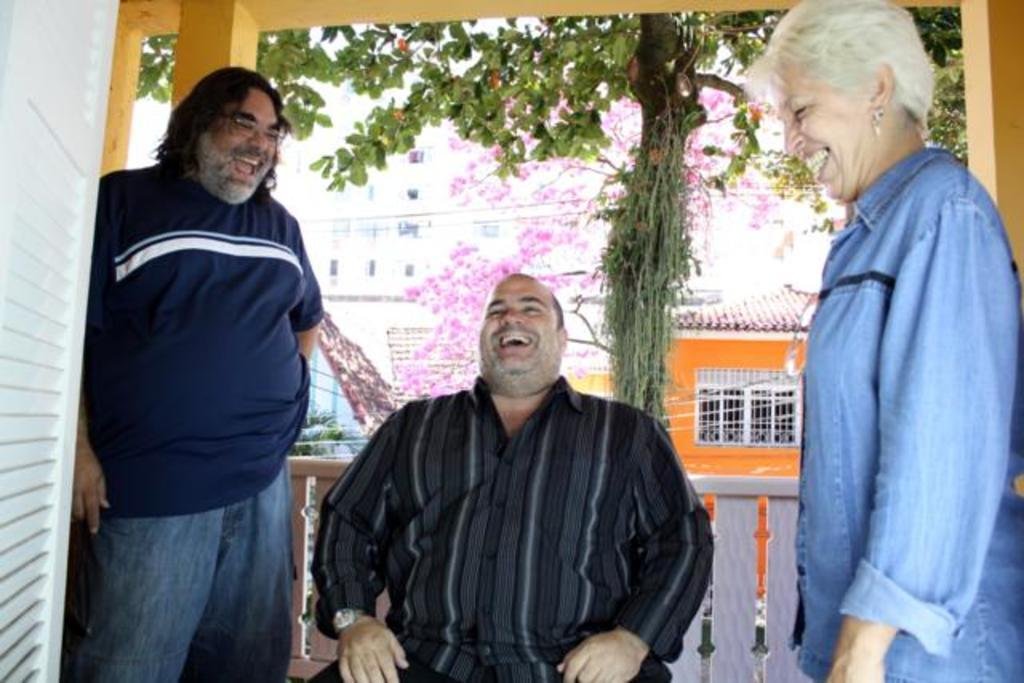How many people are in the image? There are three persons in the image. What are the positions of the people in the image? One person is sitting, and two persons are standing. What can be seen in the middle of the image? There is a tree and a building in the middle of the image. What type of fiction is the person reading in the image? There is no indication in the image that any person is reading fiction or any other material. 